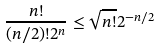Convert formula to latex. <formula><loc_0><loc_0><loc_500><loc_500>\frac { n ! } { ( n / 2 ) ! 2 ^ { n } } \leq \sqrt { n ! } 2 ^ { - n / 2 }</formula> 